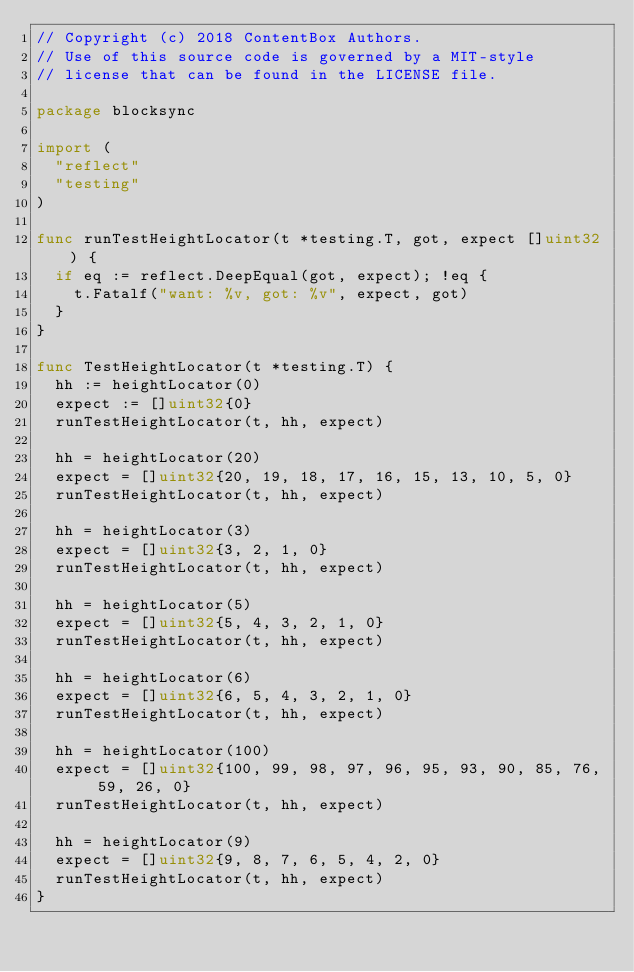Convert code to text. <code><loc_0><loc_0><loc_500><loc_500><_Go_>// Copyright (c) 2018 ContentBox Authors.
// Use of this source code is governed by a MIT-style
// license that can be found in the LICENSE file.

package blocksync

import (
	"reflect"
	"testing"
)

func runTestHeightLocator(t *testing.T, got, expect []uint32) {
	if eq := reflect.DeepEqual(got, expect); !eq {
		t.Fatalf("want: %v, got: %v", expect, got)
	}
}

func TestHeightLocator(t *testing.T) {
	hh := heightLocator(0)
	expect := []uint32{0}
	runTestHeightLocator(t, hh, expect)

	hh = heightLocator(20)
	expect = []uint32{20, 19, 18, 17, 16, 15, 13, 10, 5, 0}
	runTestHeightLocator(t, hh, expect)

	hh = heightLocator(3)
	expect = []uint32{3, 2, 1, 0}
	runTestHeightLocator(t, hh, expect)

	hh = heightLocator(5)
	expect = []uint32{5, 4, 3, 2, 1, 0}
	runTestHeightLocator(t, hh, expect)

	hh = heightLocator(6)
	expect = []uint32{6, 5, 4, 3, 2, 1, 0}
	runTestHeightLocator(t, hh, expect)

	hh = heightLocator(100)
	expect = []uint32{100, 99, 98, 97, 96, 95, 93, 90, 85, 76, 59, 26, 0}
	runTestHeightLocator(t, hh, expect)

	hh = heightLocator(9)
	expect = []uint32{9, 8, 7, 6, 5, 4, 2, 0}
	runTestHeightLocator(t, hh, expect)
}
</code> 